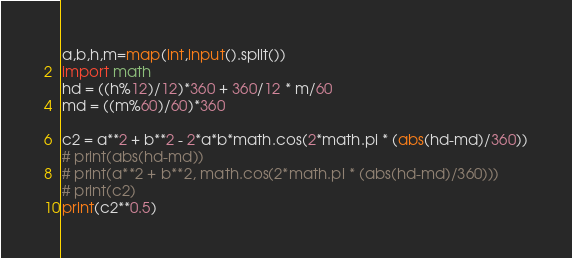Convert code to text. <code><loc_0><loc_0><loc_500><loc_500><_Python_>a,b,h,m=map(int,input().split())
import math
hd = ((h%12)/12)*360 + 360/12 * m/60
md = ((m%60)/60)*360

c2 = a**2 + b**2 - 2*a*b*math.cos(2*math.pi * (abs(hd-md)/360))
# print(abs(hd-md))
# print(a**2 + b**2, math.cos(2*math.pi * (abs(hd-md)/360)))
# print(c2)
print(c2**0.5)</code> 